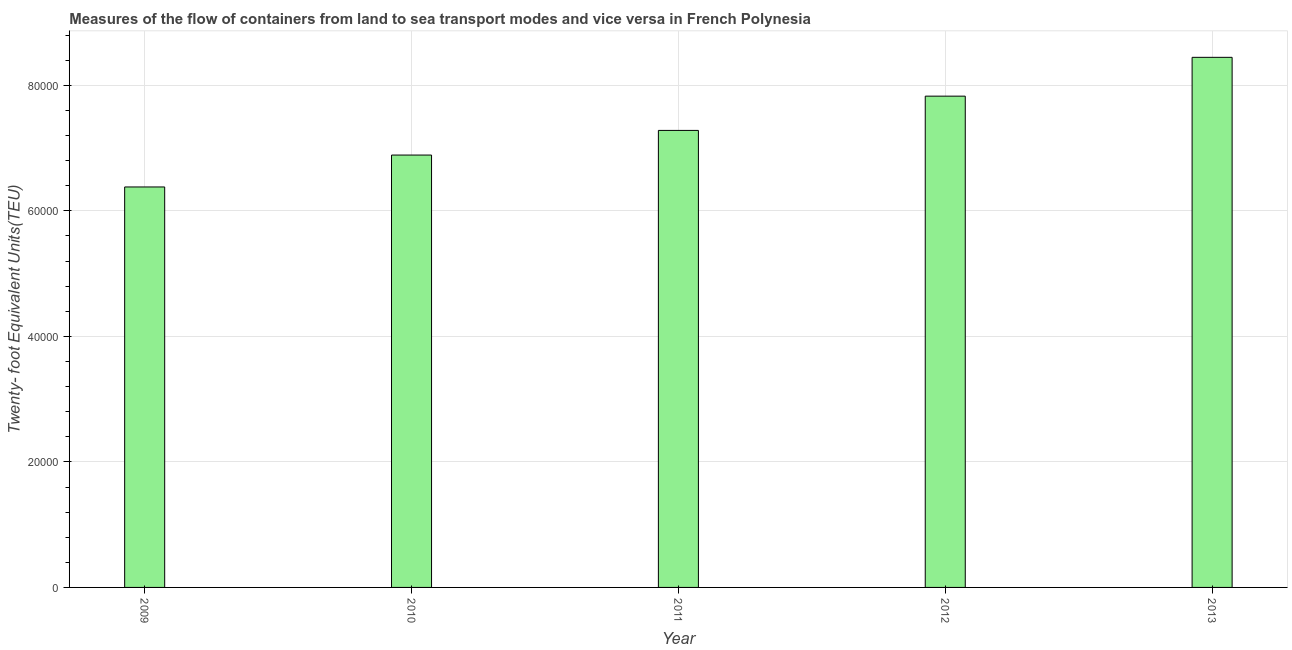Does the graph contain any zero values?
Keep it short and to the point. No. What is the title of the graph?
Keep it short and to the point. Measures of the flow of containers from land to sea transport modes and vice versa in French Polynesia. What is the label or title of the X-axis?
Your answer should be very brief. Year. What is the label or title of the Y-axis?
Offer a terse response. Twenty- foot Equivalent Units(TEU). What is the container port traffic in 2009?
Offer a very short reply. 6.38e+04. Across all years, what is the maximum container port traffic?
Provide a short and direct response. 8.45e+04. Across all years, what is the minimum container port traffic?
Offer a very short reply. 6.38e+04. In which year was the container port traffic maximum?
Give a very brief answer. 2013. What is the sum of the container port traffic?
Offer a terse response. 3.68e+05. What is the difference between the container port traffic in 2012 and 2013?
Offer a terse response. -6183.87. What is the average container port traffic per year?
Your response must be concise. 7.36e+04. What is the median container port traffic?
Your answer should be compact. 7.28e+04. Do a majority of the years between 2009 and 2012 (inclusive) have container port traffic greater than 44000 TEU?
Give a very brief answer. Yes. What is the ratio of the container port traffic in 2011 to that in 2012?
Your answer should be compact. 0.93. Is the container port traffic in 2010 less than that in 2012?
Your response must be concise. Yes. Is the difference between the container port traffic in 2009 and 2012 greater than the difference between any two years?
Provide a short and direct response. No. What is the difference between the highest and the second highest container port traffic?
Give a very brief answer. 6183.87. What is the difference between the highest and the lowest container port traffic?
Provide a succinct answer. 2.07e+04. Are all the bars in the graph horizontal?
Offer a very short reply. No. How many years are there in the graph?
Make the answer very short. 5. What is the Twenty- foot Equivalent Units(TEU) of 2009?
Your response must be concise. 6.38e+04. What is the Twenty- foot Equivalent Units(TEU) of 2010?
Provide a succinct answer. 6.89e+04. What is the Twenty- foot Equivalent Units(TEU) in 2011?
Ensure brevity in your answer.  7.28e+04. What is the Twenty- foot Equivalent Units(TEU) in 2012?
Your answer should be compact. 7.83e+04. What is the Twenty- foot Equivalent Units(TEU) of 2013?
Make the answer very short. 8.45e+04. What is the difference between the Twenty- foot Equivalent Units(TEU) in 2009 and 2010?
Provide a succinct answer. -5082. What is the difference between the Twenty- foot Equivalent Units(TEU) in 2009 and 2011?
Ensure brevity in your answer.  -9008.67. What is the difference between the Twenty- foot Equivalent Units(TEU) in 2009 and 2012?
Your response must be concise. -1.45e+04. What is the difference between the Twenty- foot Equivalent Units(TEU) in 2009 and 2013?
Give a very brief answer. -2.07e+04. What is the difference between the Twenty- foot Equivalent Units(TEU) in 2010 and 2011?
Provide a succinct answer. -3926.67. What is the difference between the Twenty- foot Equivalent Units(TEU) in 2010 and 2012?
Give a very brief answer. -9387.85. What is the difference between the Twenty- foot Equivalent Units(TEU) in 2010 and 2013?
Your answer should be very brief. -1.56e+04. What is the difference between the Twenty- foot Equivalent Units(TEU) in 2011 and 2012?
Your answer should be compact. -5461.18. What is the difference between the Twenty- foot Equivalent Units(TEU) in 2011 and 2013?
Offer a terse response. -1.16e+04. What is the difference between the Twenty- foot Equivalent Units(TEU) in 2012 and 2013?
Offer a very short reply. -6183.87. What is the ratio of the Twenty- foot Equivalent Units(TEU) in 2009 to that in 2010?
Ensure brevity in your answer.  0.93. What is the ratio of the Twenty- foot Equivalent Units(TEU) in 2009 to that in 2011?
Your answer should be very brief. 0.88. What is the ratio of the Twenty- foot Equivalent Units(TEU) in 2009 to that in 2012?
Provide a succinct answer. 0.81. What is the ratio of the Twenty- foot Equivalent Units(TEU) in 2009 to that in 2013?
Ensure brevity in your answer.  0.76. What is the ratio of the Twenty- foot Equivalent Units(TEU) in 2010 to that in 2011?
Give a very brief answer. 0.95. What is the ratio of the Twenty- foot Equivalent Units(TEU) in 2010 to that in 2013?
Provide a succinct answer. 0.82. What is the ratio of the Twenty- foot Equivalent Units(TEU) in 2011 to that in 2012?
Keep it short and to the point. 0.93. What is the ratio of the Twenty- foot Equivalent Units(TEU) in 2011 to that in 2013?
Provide a short and direct response. 0.86. What is the ratio of the Twenty- foot Equivalent Units(TEU) in 2012 to that in 2013?
Provide a short and direct response. 0.93. 